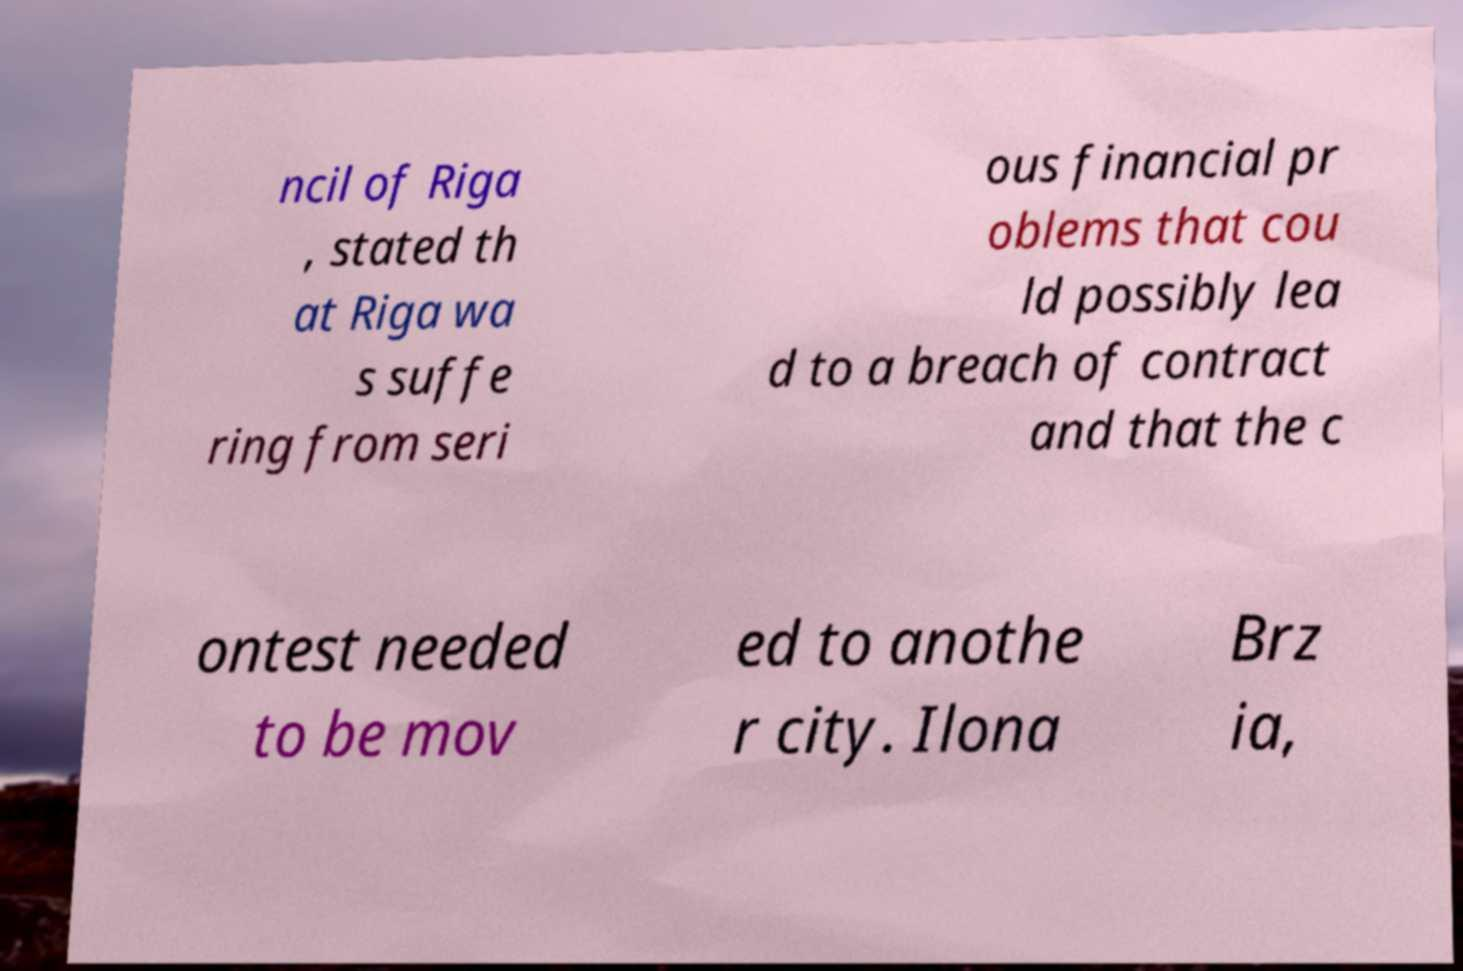For documentation purposes, I need the text within this image transcribed. Could you provide that? ncil of Riga , stated th at Riga wa s suffe ring from seri ous financial pr oblems that cou ld possibly lea d to a breach of contract and that the c ontest needed to be mov ed to anothe r city. Ilona Brz ia, 